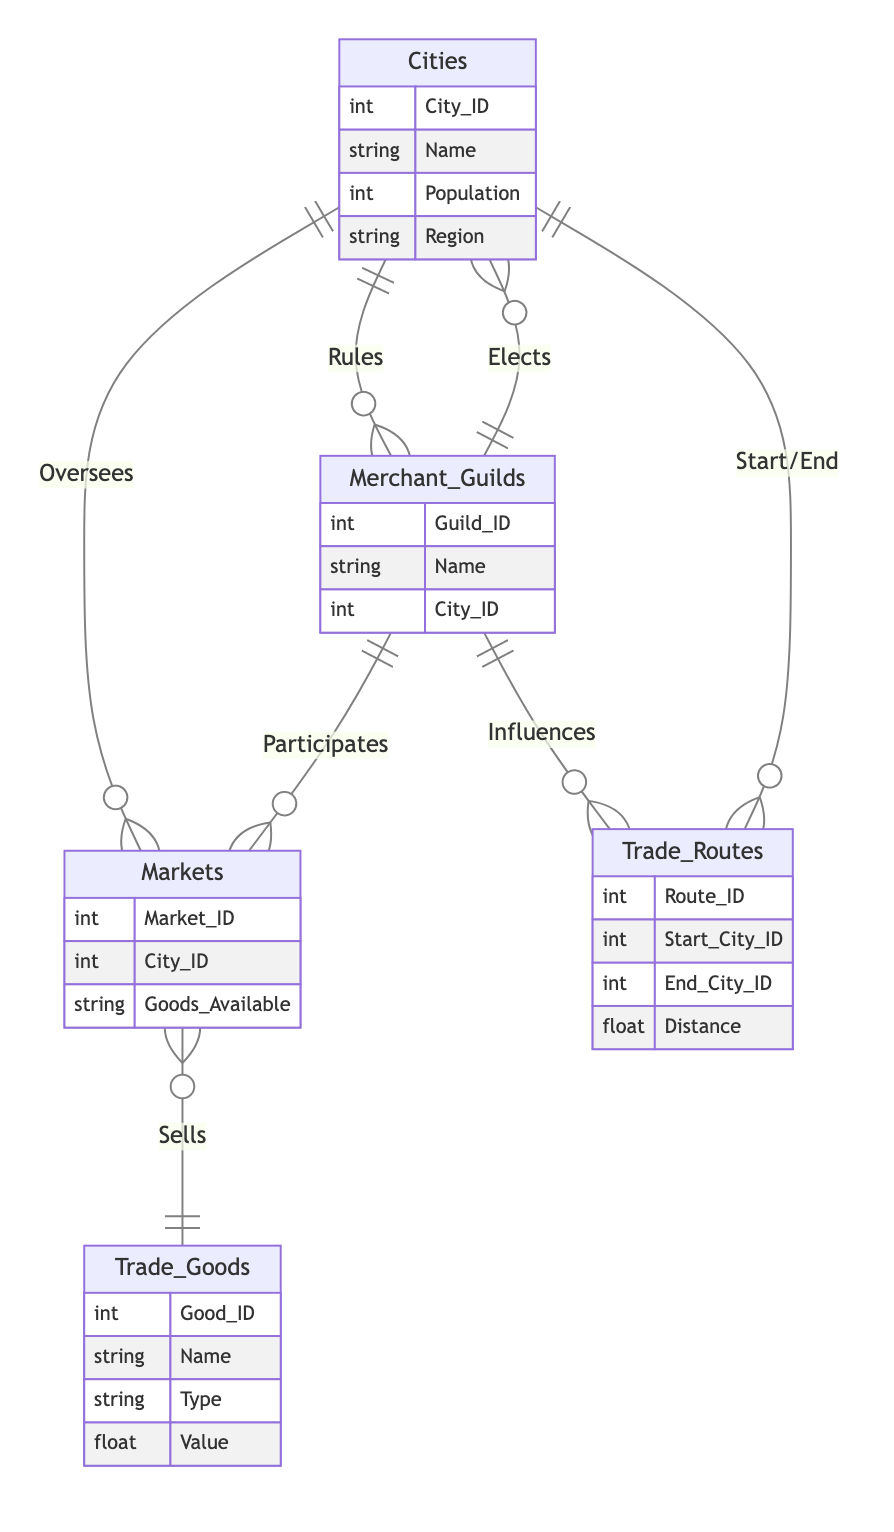What is the primary role of Cities in relation to Markets? Cities have an overseeing role towards Markets, indicating a form of governance or supervision. This is indicated by the "Oversees" relationship connecting these entities.
Answer: Oversees How many main entities are represented in the diagram? The diagram contains five main entities: Cities, Merchant Guilds, Trade Goods, Trade Routes, and Markets. This can be counted directly from the entities section of the diagram.
Answer: 5 What relationship exists between Merchant Guilds and Trade Routes? The specific relationship between Merchant Guilds and Trade Routes is termed "Influences," suggesting that Merchant Guilds have an impact or control over Trade Routes.
Answer: Influences Which entity participates in Markets? The entity that participates in Markets is Merchant Guilds. The "Participates" relationship indicates that Merchant Guilds are active in the Market entity.
Answer: Merchant Guilds How many relationships are outlined in the diagram? There are five relationships defined in the diagram linking the entities, which can be determined by counting each relationship in the relationships section.
Answer: 5 Which entity is ruled by Cities? The entity that is ruled by Cities is Merchant Guilds. The "Rules" relationship shows that Cities have authority over Merchant Guilds.
Answer: Merchant Guilds What is the relationship called that connects Cities and Merchant Guilds in terms of elections? The relationship that connects Cities and Merchant Guilds regarding elections is called "Elects." This indicates that Merchant Guilds have the power to elect concerning Cities.
Answer: Elects Which entity has goods available in Markets? The entity that has goods available in Markets is Trade Goods. The "Sells" relationship specifies that Markets offer Trade Goods for sale.
Answer: Trade Goods What attribute relates to the governing powers of Cities over Markets? The attribute related to the governing powers of Cities over Markets is "Oversight_Detail," which specifies the nature of the oversight that Cities exercise over Markets.
Answer: Oversight_Detail 